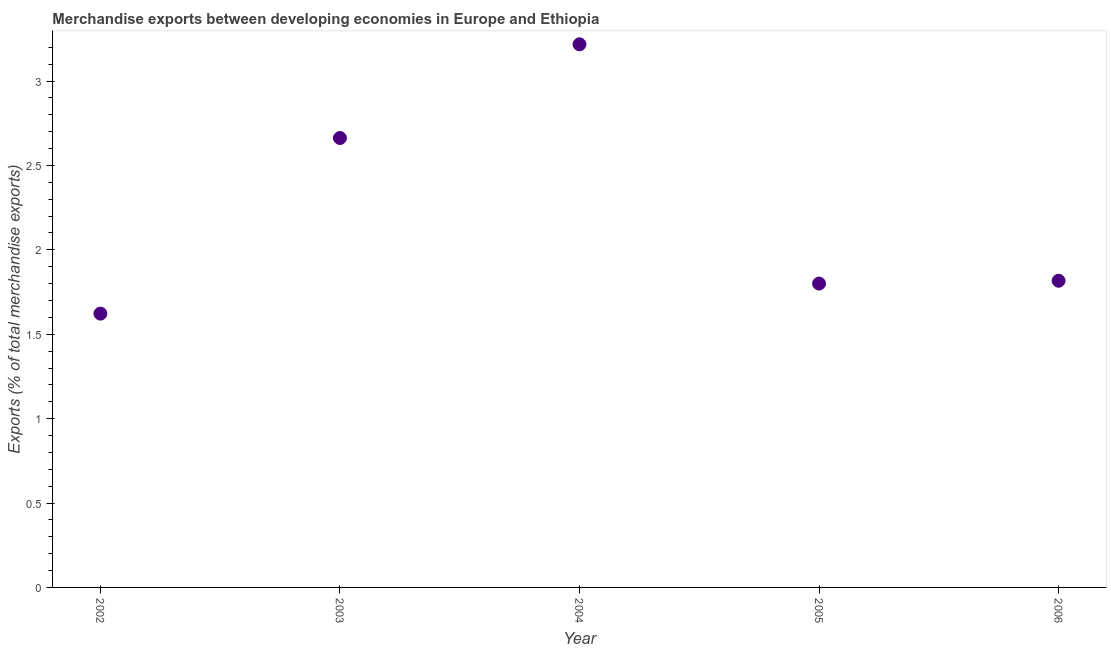What is the merchandise exports in 2004?
Keep it short and to the point. 3.22. Across all years, what is the maximum merchandise exports?
Your response must be concise. 3.22. Across all years, what is the minimum merchandise exports?
Your response must be concise. 1.62. In which year was the merchandise exports maximum?
Your answer should be very brief. 2004. What is the sum of the merchandise exports?
Your response must be concise. 11.12. What is the difference between the merchandise exports in 2003 and 2006?
Your answer should be very brief. 0.85. What is the average merchandise exports per year?
Offer a terse response. 2.22. What is the median merchandise exports?
Ensure brevity in your answer.  1.82. In how many years, is the merchandise exports greater than 0.7 %?
Provide a succinct answer. 5. What is the ratio of the merchandise exports in 2005 to that in 2006?
Keep it short and to the point. 0.99. Is the merchandise exports in 2004 less than that in 2005?
Your response must be concise. No. Is the difference between the merchandise exports in 2002 and 2006 greater than the difference between any two years?
Offer a very short reply. No. What is the difference between the highest and the second highest merchandise exports?
Offer a very short reply. 0.56. What is the difference between the highest and the lowest merchandise exports?
Ensure brevity in your answer.  1.6. Does the merchandise exports monotonically increase over the years?
Make the answer very short. No. Are the values on the major ticks of Y-axis written in scientific E-notation?
Your response must be concise. No. Does the graph contain any zero values?
Keep it short and to the point. No. Does the graph contain grids?
Your answer should be compact. No. What is the title of the graph?
Ensure brevity in your answer.  Merchandise exports between developing economies in Europe and Ethiopia. What is the label or title of the Y-axis?
Offer a terse response. Exports (% of total merchandise exports). What is the Exports (% of total merchandise exports) in 2002?
Your response must be concise. 1.62. What is the Exports (% of total merchandise exports) in 2003?
Keep it short and to the point. 2.66. What is the Exports (% of total merchandise exports) in 2004?
Give a very brief answer. 3.22. What is the Exports (% of total merchandise exports) in 2005?
Ensure brevity in your answer.  1.8. What is the Exports (% of total merchandise exports) in 2006?
Offer a terse response. 1.82. What is the difference between the Exports (% of total merchandise exports) in 2002 and 2003?
Ensure brevity in your answer.  -1.04. What is the difference between the Exports (% of total merchandise exports) in 2002 and 2004?
Your answer should be compact. -1.6. What is the difference between the Exports (% of total merchandise exports) in 2002 and 2005?
Ensure brevity in your answer.  -0.18. What is the difference between the Exports (% of total merchandise exports) in 2002 and 2006?
Offer a very short reply. -0.19. What is the difference between the Exports (% of total merchandise exports) in 2003 and 2004?
Give a very brief answer. -0.56. What is the difference between the Exports (% of total merchandise exports) in 2003 and 2005?
Ensure brevity in your answer.  0.86. What is the difference between the Exports (% of total merchandise exports) in 2003 and 2006?
Make the answer very short. 0.85. What is the difference between the Exports (% of total merchandise exports) in 2004 and 2005?
Your answer should be compact. 1.42. What is the difference between the Exports (% of total merchandise exports) in 2004 and 2006?
Offer a terse response. 1.4. What is the difference between the Exports (% of total merchandise exports) in 2005 and 2006?
Your response must be concise. -0.02. What is the ratio of the Exports (% of total merchandise exports) in 2002 to that in 2003?
Your answer should be compact. 0.61. What is the ratio of the Exports (% of total merchandise exports) in 2002 to that in 2004?
Keep it short and to the point. 0.5. What is the ratio of the Exports (% of total merchandise exports) in 2002 to that in 2005?
Offer a terse response. 0.9. What is the ratio of the Exports (% of total merchandise exports) in 2002 to that in 2006?
Your answer should be very brief. 0.89. What is the ratio of the Exports (% of total merchandise exports) in 2003 to that in 2004?
Give a very brief answer. 0.83. What is the ratio of the Exports (% of total merchandise exports) in 2003 to that in 2005?
Offer a very short reply. 1.48. What is the ratio of the Exports (% of total merchandise exports) in 2003 to that in 2006?
Provide a short and direct response. 1.47. What is the ratio of the Exports (% of total merchandise exports) in 2004 to that in 2005?
Your response must be concise. 1.79. What is the ratio of the Exports (% of total merchandise exports) in 2004 to that in 2006?
Make the answer very short. 1.77. What is the ratio of the Exports (% of total merchandise exports) in 2005 to that in 2006?
Offer a very short reply. 0.99. 